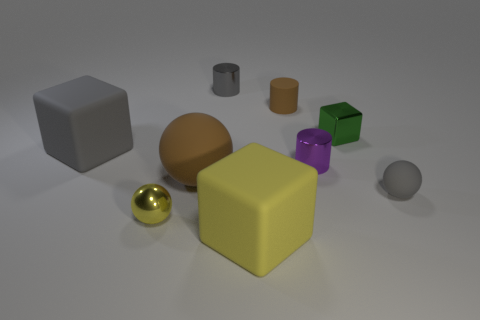Subtract all matte balls. How many balls are left? 1 Subtract 1 spheres. How many spheres are left? 2 Subtract all cylinders. How many objects are left? 6 Add 2 green things. How many green things are left? 3 Add 2 small cyan rubber things. How many small cyan rubber things exist? 2 Subtract 1 green blocks. How many objects are left? 8 Subtract all red matte balls. Subtract all shiny cubes. How many objects are left? 8 